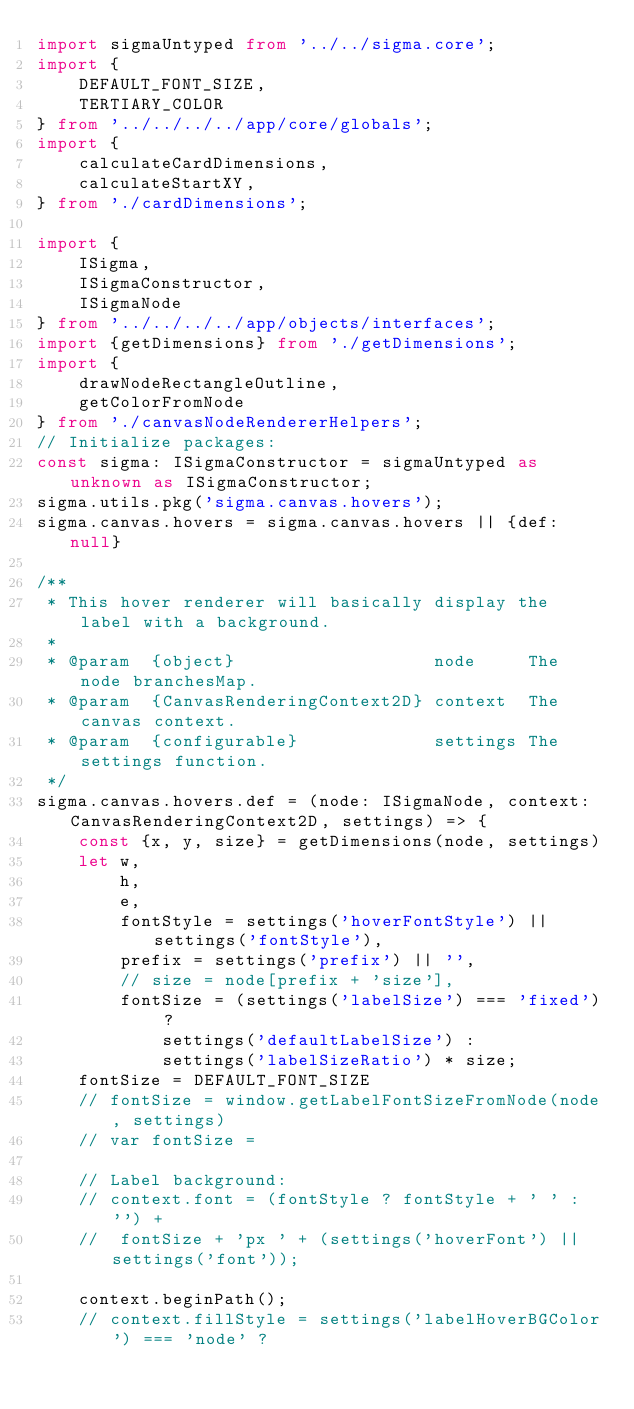<code> <loc_0><loc_0><loc_500><loc_500><_TypeScript_>import sigmaUntyped	from '../../sigma.core';
import {
	DEFAULT_FONT_SIZE,
	TERTIARY_COLOR
} from '../../../../app/core/globals';
import {
	calculateCardDimensions,
	calculateStartXY,
} from './cardDimensions';

import {
	ISigma,
	ISigmaConstructor,
	ISigmaNode
} from '../../../../app/objects/interfaces';
import {getDimensions} from './getDimensions';
import {
	drawNodeRectangleOutline,
	getColorFromNode
} from './canvasNodeRendererHelpers';
// Initialize packages:
const sigma: ISigmaConstructor = sigmaUntyped as unknown as ISigmaConstructor;
sigma.utils.pkg('sigma.canvas.hovers');
sigma.canvas.hovers = sigma.canvas.hovers || {def: null}

/**
 * This hover renderer will basically display the label with a background.
 *
 * @param  {object}                   node     The node branchesMap.
 * @param  {CanvasRenderingContext2D} context  The canvas context.
 * @param  {configurable}             settings The settings function.
 */
sigma.canvas.hovers.def = (node: ISigmaNode, context: CanvasRenderingContext2D, settings) => {
	const {x, y, size} = getDimensions(node, settings)
	let	w,
		h,
		e,
		fontStyle = settings('hoverFontStyle') || settings('fontStyle'),
		prefix = settings('prefix') || '',
		// size = node[prefix + 'size'],
		fontSize = (settings('labelSize') === 'fixed') ?
			settings('defaultLabelSize') :
			settings('labelSizeRatio') * size;
	fontSize = DEFAULT_FONT_SIZE
	// fontSize = window.getLabelFontSizeFromNode(node, settings)
	// var fontSize =

	// Label background:
	// context.font = (fontStyle ? fontStyle + ' ' : '') +
	// 	fontSize + 'px ' + (settings('hoverFont') || settings('font'));

	context.beginPath();
	// context.fillStyle = settings('labelHoverBGColor') === 'node' ?</code> 